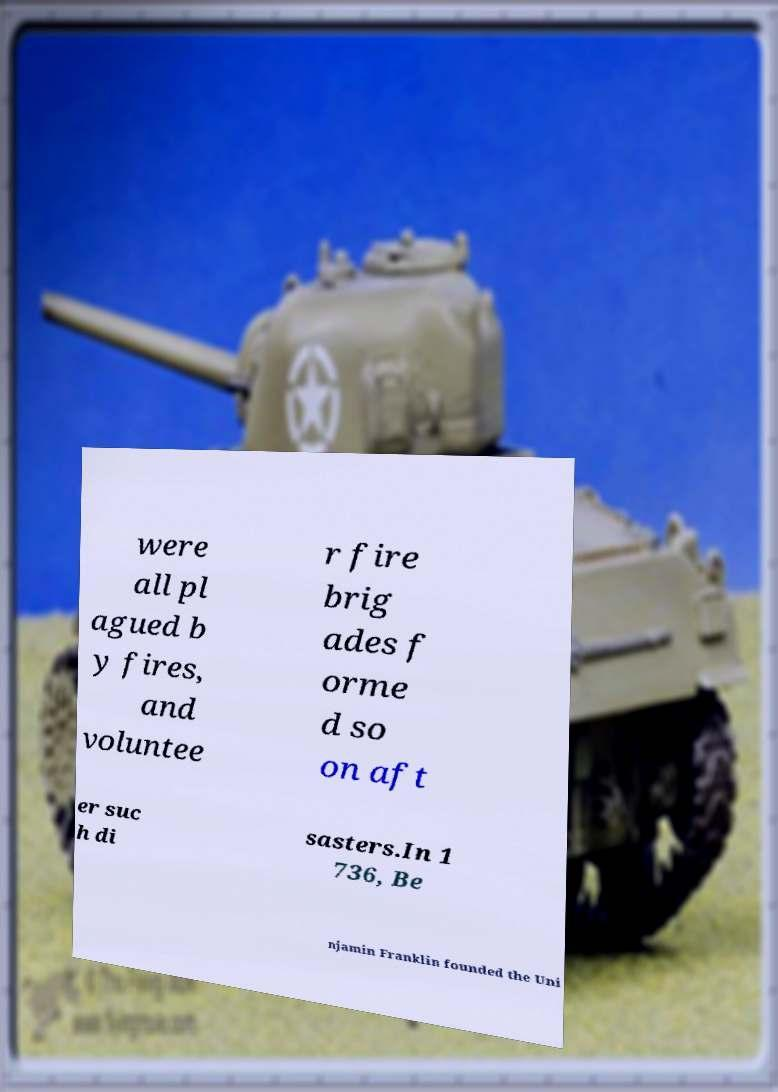There's text embedded in this image that I need extracted. Can you transcribe it verbatim? were all pl agued b y fires, and voluntee r fire brig ades f orme d so on aft er suc h di sasters.In 1 736, Be njamin Franklin founded the Uni 